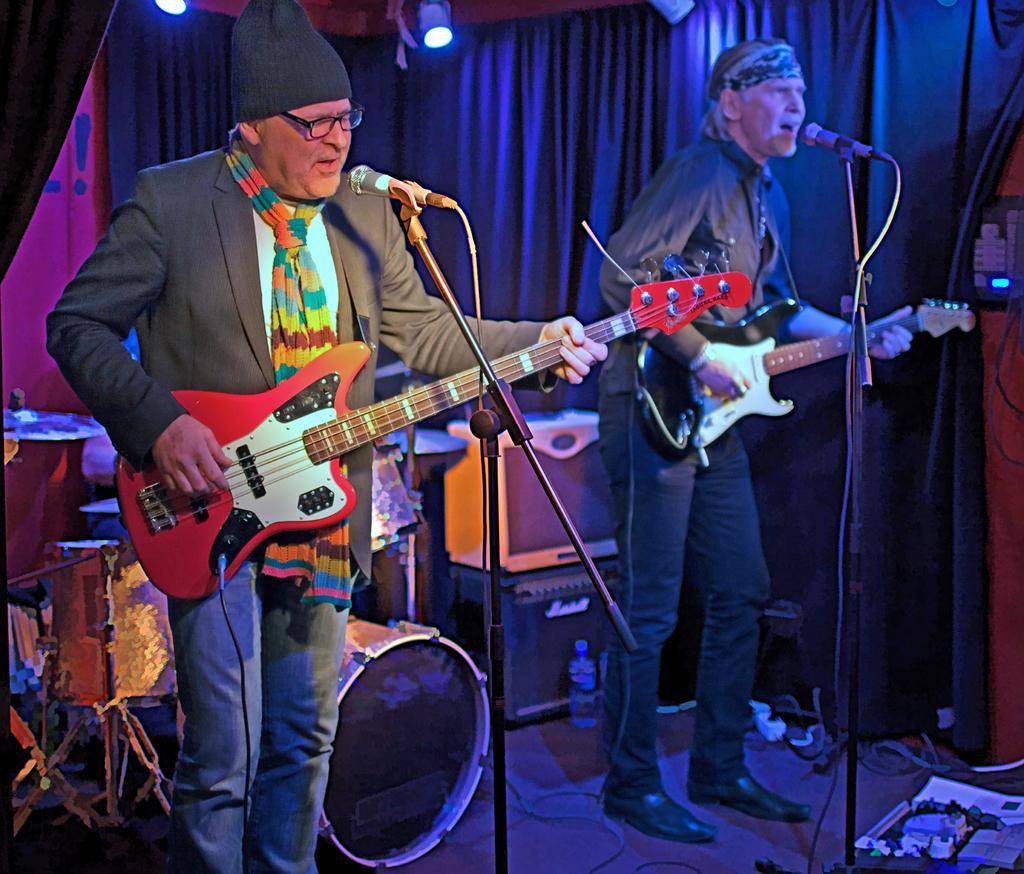In one or two sentences, can you explain what this image depicts? There are two persons standing and holding a guitars and performing on the stage as we can see in the middle of this image. There is a curtain in the background. There are some lights as we can see at the top of this image, and there is a band on the left side of this image. 